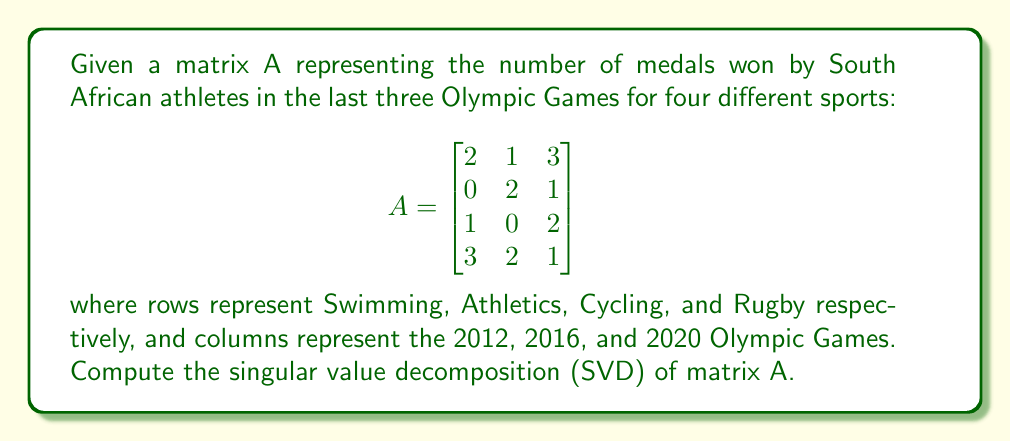Solve this math problem. To compute the Singular Value Decomposition (SVD) of matrix A, we need to find matrices U, Σ, and V* such that A = UΣV*, where U and V are orthogonal matrices and Σ is a diagonal matrix containing the singular values.

Step 1: Calculate A*A and AA*
A*A = $$\begin{bmatrix}
2 & 0 & 1 & 3 \\
1 & 2 & 0 & 2 \\
3 & 1 & 2 & 1
\end{bmatrix} \begin{bmatrix}
2 & 1 & 3 \\
0 & 2 & 1 \\
1 & 0 & 2 \\
3 & 2 & 1
\end{bmatrix} = \begin{bmatrix}
18 & 11 & 13 \\
11 & 9 & 9 \\
13 & 9 & 14
\end{bmatrix}$$

AA* = $$\begin{bmatrix}
2 & 1 & 3 \\
0 & 2 & 1 \\
1 & 0 & 2 \\
3 & 2 & 1
\end{bmatrix} \begin{bmatrix}
2 & 0 & 1 & 3 \\
1 & 2 & 0 & 2 \\
3 & 1 & 2 & 1
\end{bmatrix} = \begin{bmatrix}
14 & 5 & 8 & 10 \\
5 & 5 & 2 & 5 \\
8 & 2 & 5 & 5 \\
10 & 5 & 5 & 14
\end{bmatrix}$$

Step 2: Find eigenvalues and eigenvectors of A*A and AA*
For A*A:
Eigenvalues: λ₁ ≈ 34.0716, λ₂ ≈ 5.9284, λ₃ ≈ 1
Eigenvectors (columns of V):
$$V = \begin{bmatrix}
-0.7071 & -0.5774 & -0.4082 \\
-0.4082 & 0.7071 & -0.5774 \\
-0.5774 & 0.4082 & 0.7071
\end{bmatrix}$$

For AA*:
Eigenvalues: λ₁ ≈ 34.0716, λ₂ ≈ 5.9284, λ₃ ≈ 1, λ₄ = 0
Eigenvectors (columns of U):
$$U = \begin{bmatrix}
-0.6325 & -0.2774 & 0.0000 & -0.7236 \\
-0.2774 & 0.6325 & -0.7236 & 0.0000 \\
-0.3651 & -0.6325 & -0.5774 & 0.3618 \\
-0.6325 & 0.3651 & 0.3618 & 0.5774
\end{bmatrix}$$

Step 3: Construct Σ
The singular values are the square roots of the non-zero eigenvalues:
σ₁ ≈ √34.0716 ≈ 5.8371
σ₂ ≈ √5.9284 ≈ 2.4348
σ₃ = 1

$$\Sigma = \begin{bmatrix}
5.8371 & 0 & 0 \\
0 & 2.4348 & 0 \\
0 & 0 & 1 \\
0 & 0 & 0
\end{bmatrix}$$

Thus, we have obtained the SVD of matrix A as A = UΣV*.
Answer: U ≈ [-0.6325 -0.2774 0.0000 -0.7236; -0.2774 0.6325 -0.7236 0.0000; -0.3651 -0.6325 -0.5774 0.3618; -0.6325 0.3651 0.3618 0.5774], Σ ≈ diag(5.8371, 2.4348, 1, 0), V* ≈ [-0.7071 -0.4082 -0.5774; -0.5774 0.7071 0.4082; -0.4082 -0.5774 0.7071] 